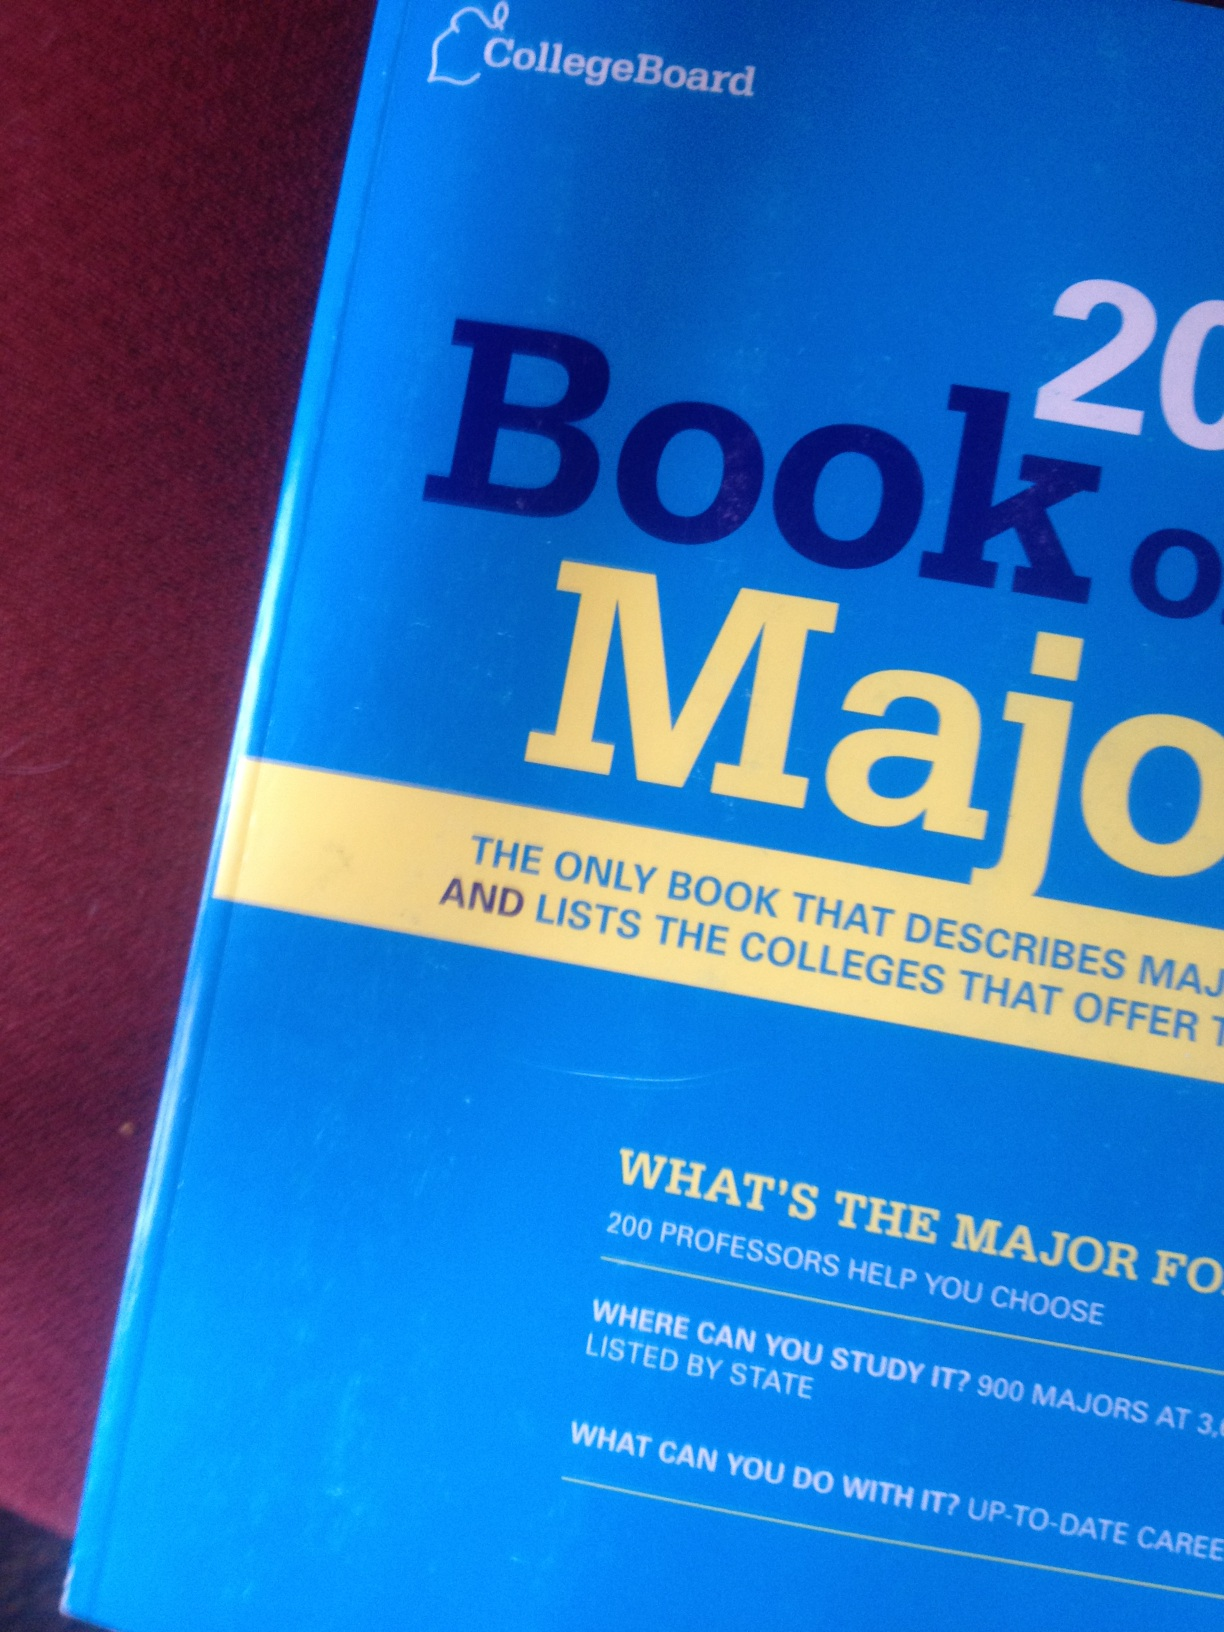Can you tell me more about the types of information included in the 'Book of Majors'? The 'Book of Majors' provides detailed descriptions of different college majors. It covers what students can expect from each major, the types of careers these majors can lead to, and which colleges offer programs in these fields. Additionally, it includes insights from professors and experts in various disciplines. 